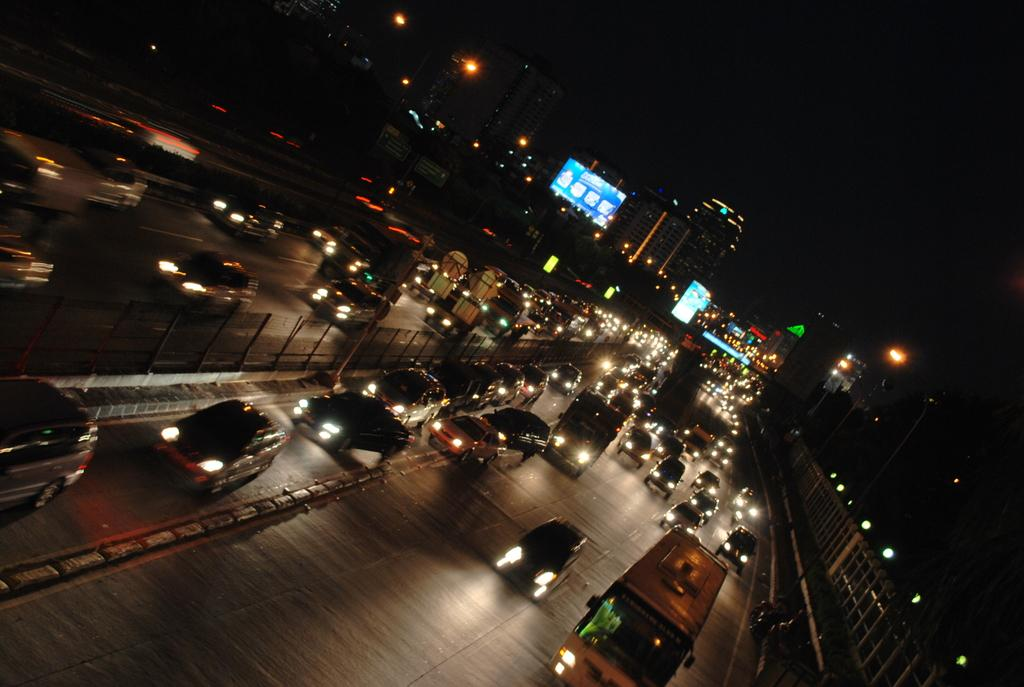What is happening on the road in the image? There are vehicles on the road in the image. What can be seen in the distance behind the vehicles? There are buildings, lights, boards, and the sky visible in the background of the image. Can you describe the objects in the background? There are some objects in the background of the image, but their specific nature is not clear from the provided facts. Where is the toothbrush located in the image? There is no toothbrush present in the image. What type of wilderness can be seen in the image? There is no wilderness present in the image; it features a road with vehicles and a background with buildings, lights, boards, and the sky. 